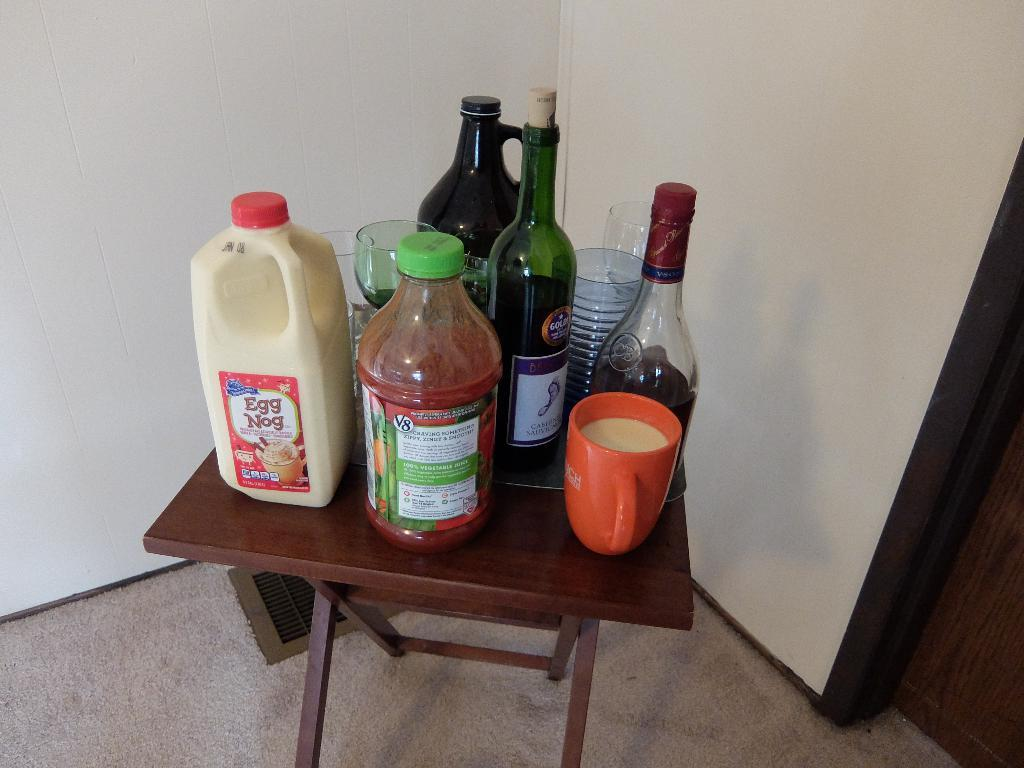<image>
Write a terse but informative summary of the picture. A bottle of Egg Nog with other drinks on a small wooden table. 